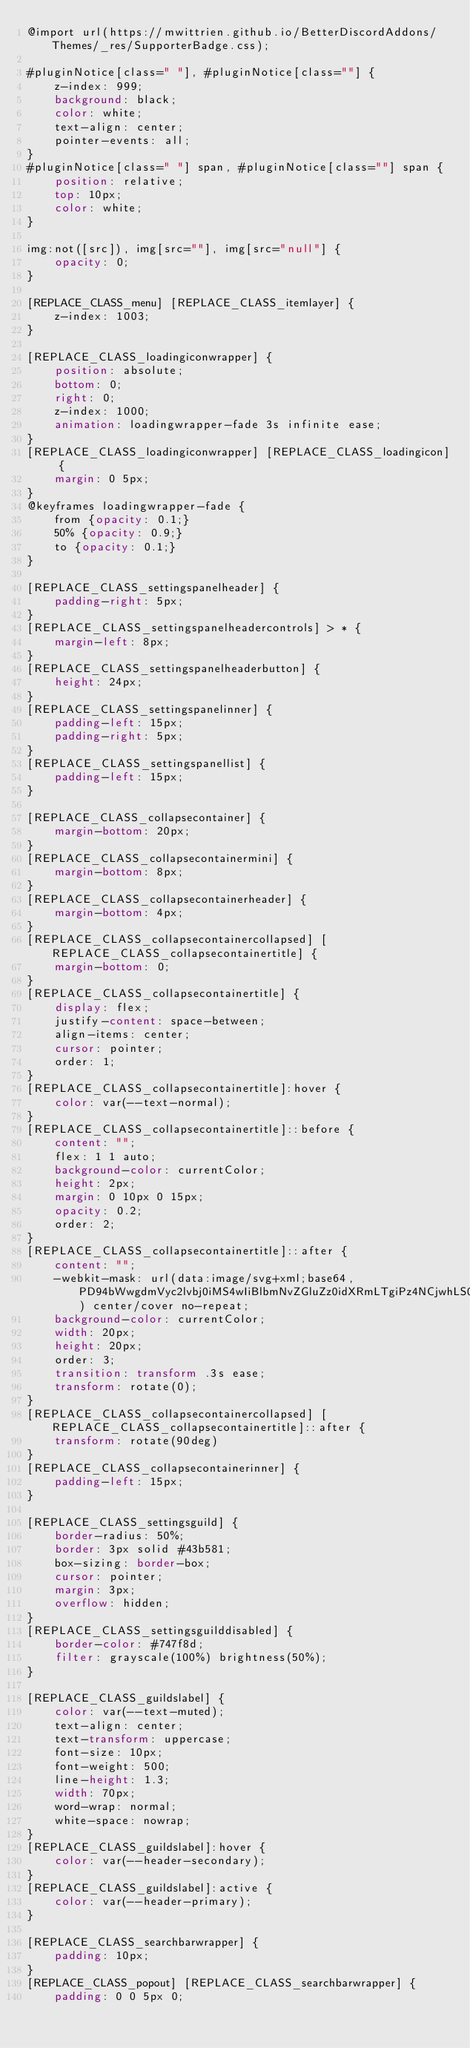<code> <loc_0><loc_0><loc_500><loc_500><_CSS_>@import url(https://mwittrien.github.io/BetterDiscordAddons/Themes/_res/SupporterBadge.css);

#pluginNotice[class=" "], #pluginNotice[class=""] {
    z-index: 999;
    background: black;
	color: white;
    text-align: center;
    pointer-events: all;
}
#pluginNotice[class=" "] span, #pluginNotice[class=""] span {
    position: relative;
    top: 10px;
    color: white;
}

img:not([src]), img[src=""], img[src="null"] {
	opacity: 0;
}

[REPLACE_CLASS_menu] [REPLACE_CLASS_itemlayer] {
	z-index: 1003;
}

[REPLACE_CLASS_loadingiconwrapper] {
	position: absolute;
	bottom: 0;
	right: 0;
	z-index: 1000;
	animation: loadingwrapper-fade 3s infinite ease;
}
[REPLACE_CLASS_loadingiconwrapper] [REPLACE_CLASS_loadingicon] {
	margin: 0 5px;
}
@keyframes loadingwrapper-fade {
	from {opacity: 0.1;}
	50% {opacity: 0.9;}
	to {opacity: 0.1;}
}

[REPLACE_CLASS_settingspanelheader] {
	padding-right: 5px;
}
[REPLACE_CLASS_settingspanelheadercontrols] > * {
	margin-left: 8px;
}
[REPLACE_CLASS_settingspanelheaderbutton] {
	height: 24px;
}
[REPLACE_CLASS_settingspanelinner] {
	padding-left: 15px;
	padding-right: 5px;
}
[REPLACE_CLASS_settingspanellist] {
	padding-left: 15px;
}

[REPLACE_CLASS_collapsecontainer] {
	margin-bottom: 20px;
}
[REPLACE_CLASS_collapsecontainermini] {
	margin-bottom: 8px;
}
[REPLACE_CLASS_collapsecontainerheader] {
	margin-bottom: 4px;
}
[REPLACE_CLASS_collapsecontainercollapsed] [REPLACE_CLASS_collapsecontainertitle] {
	margin-bottom: 0;
}
[REPLACE_CLASS_collapsecontainertitle] {
	display: flex;
	justify-content: space-between;
	align-items: center;
	cursor: pointer;
	order: 1;
}
[REPLACE_CLASS_collapsecontainertitle]:hover {
	color: var(--text-normal);
}
[REPLACE_CLASS_collapsecontainertitle]::before {
	content: "";
	flex: 1 1 auto;
	background-color: currentColor;
	height: 2px;
	margin: 0 10px 0 15px;
	opacity: 0.2;
	order: 2;
}
[REPLACE_CLASS_collapsecontainertitle]::after {
	content: "";
	-webkit-mask: url(data:image/svg+xml;base64,PD94bWwgdmVyc2lvbj0iMS4wIiBlbmNvZGluZz0idXRmLTgiPz4NCjwhLS0gR2VuZXJhdG9yOiBBZG9iZSBJbGx1c3RyYXRvciAxOS4wLjAsIFNWRyBFeHBvcnQgUGx1Zy1JbiAuIFNWRyBWZXJzaW9uOiA2LjAwIEJ1aWxkIDApICAtLT4NCjxzdmcgdmVyc2lvbj0iMS4xIiBpZD0iQ2FscXVlXzEiIHhtbG5zPSJodHRwOi8vd3d3LnczLm9yZy8yMDAwL3N2ZyIgeG1sbnM6eGxpbms9Imh0dHA6Ly93d3cudzMub3JnLzE5OTkveGxpbmsiIHg9IjBweCIgeT0iMHB4Ig0KCSB2aWV3Qm94PSItOTUwIDUzMiAxOCAxOCIgc3R5bGU9ImVuYWJsZS1iYWNrZ3JvdW5kOm5ldyAtOTUwIDUzMiAxOCAxODsiIHhtbDpzcGFjZT0icHJlc2VydmUiPg0KPHN0eWxlIHR5cGU9InRleHQvY3NzIj4NCgkuc3Qwe2ZpbGw6bm9uZTt9DQoJLnN0MXtmaWxsOm5vbmU7c3Ryb2tlOiNGRkZGRkY7c3Ryb2tlLXdpZHRoOjEuNTtzdHJva2UtbWl0ZXJsaW1pdDoxMDt9DQo8L3N0eWxlPg0KPHBhdGggY2xhc3M9InN0MCIgZD0iTS05MzIsNTMydjE4aC0xOHYtMThILTkzMnoiLz4NCjxwb2x5bGluZSBjbGFzcz0ic3QxIiBwb2ludHM9Ii05MzYuNiw1MzguOCAtOTQxLDU0My4yIC05NDUuNCw1MzguOCAiLz4NCjwvc3ZnPg0K) center/cover no-repeat;
	background-color: currentColor;
	width: 20px;
	height: 20px;
	order: 3;
	transition: transform .3s ease;
	transform: rotate(0);
}
[REPLACE_CLASS_collapsecontainercollapsed] [REPLACE_CLASS_collapsecontainertitle]::after {
	transform: rotate(90deg)
}
[REPLACE_CLASS_collapsecontainerinner] {
	padding-left: 15px;
}

[REPLACE_CLASS_settingsguild] {
	border-radius: 50%;
	border: 3px solid #43b581;
	box-sizing: border-box;
	cursor: pointer;
	margin: 3px;
	overflow: hidden;
}
[REPLACE_CLASS_settingsguilddisabled] {
	border-color: #747f8d;
	filter: grayscale(100%) brightness(50%);
}

[REPLACE_CLASS_guildslabel] {
	color: var(--text-muted);
	text-align: center;
	text-transform: uppercase;
	font-size: 10px;
	font-weight: 500;
	line-height: 1.3;
	width: 70px;
	word-wrap: normal;
	white-space: nowrap;
}
[REPLACE_CLASS_guildslabel]:hover {
	color: var(--header-secondary);
}
[REPLACE_CLASS_guildslabel]:active {
	color: var(--header-primary);
}

[REPLACE_CLASS_searchbarwrapper] {
	padding: 10px;
}
[REPLACE_CLASS_popout] [REPLACE_CLASS_searchbarwrapper] {
	padding: 0 0 5px 0;</code> 